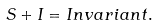Convert formula to latex. <formula><loc_0><loc_0><loc_500><loc_500>S + I = I n v a r i a n t .</formula> 